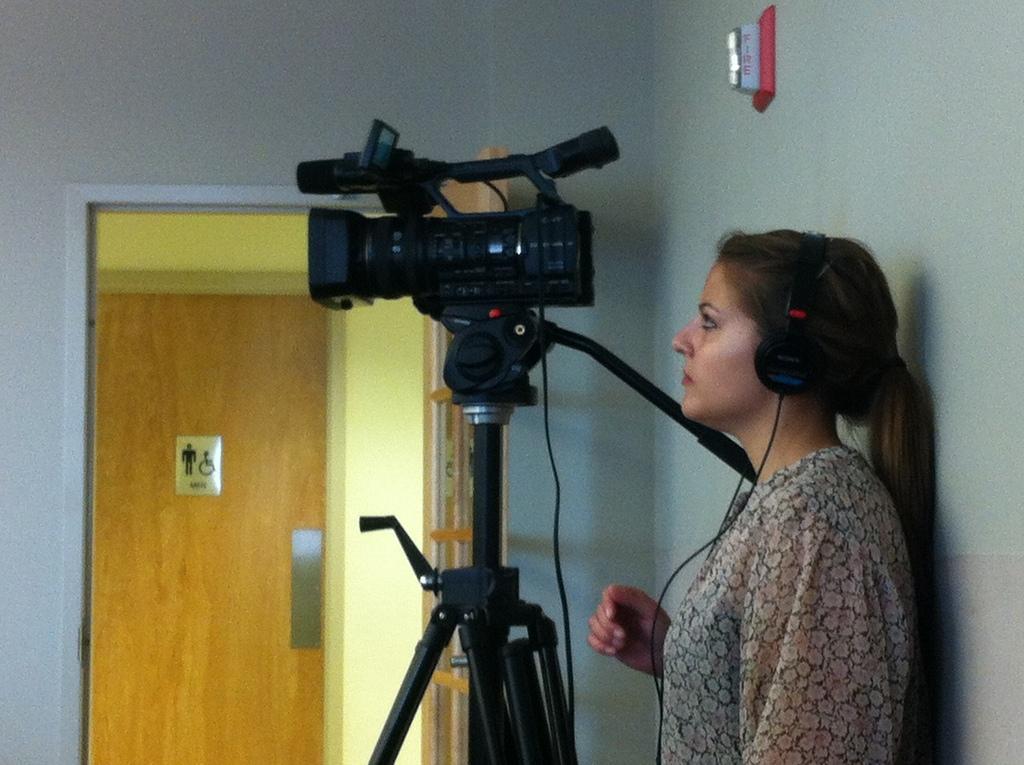Please provide a concise description of this image. In this image I can see a person is wearing headsets. In front I can see the camera on the stand. Back I can see the door and the wall. 